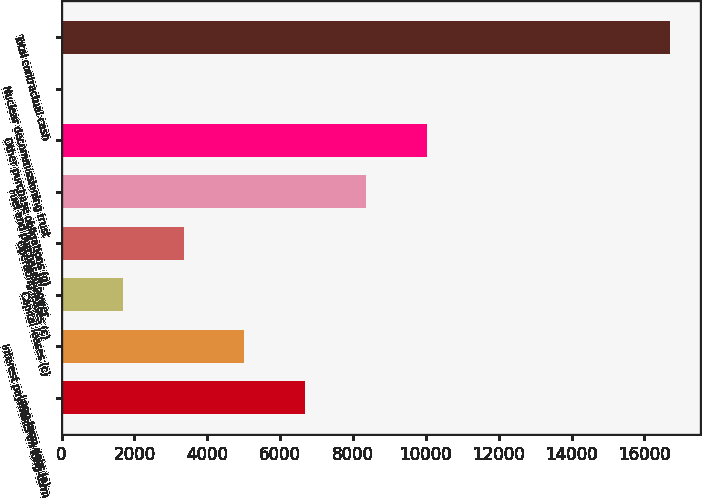Convert chart to OTSL. <chart><loc_0><loc_0><loc_500><loc_500><bar_chart><fcel>Long-term debt (a)<fcel>Interest payments on long-term<fcel>Capital leases (c)<fcel>Operating leases (c)<fcel>Fuel and purchased power<fcel>Other purchase obligations (g)<fcel>Nuclear decommissioning trust<fcel>Total contractual cash<nl><fcel>6690<fcel>5021<fcel>1683<fcel>3352<fcel>8359<fcel>10028<fcel>14<fcel>16704<nl></chart> 